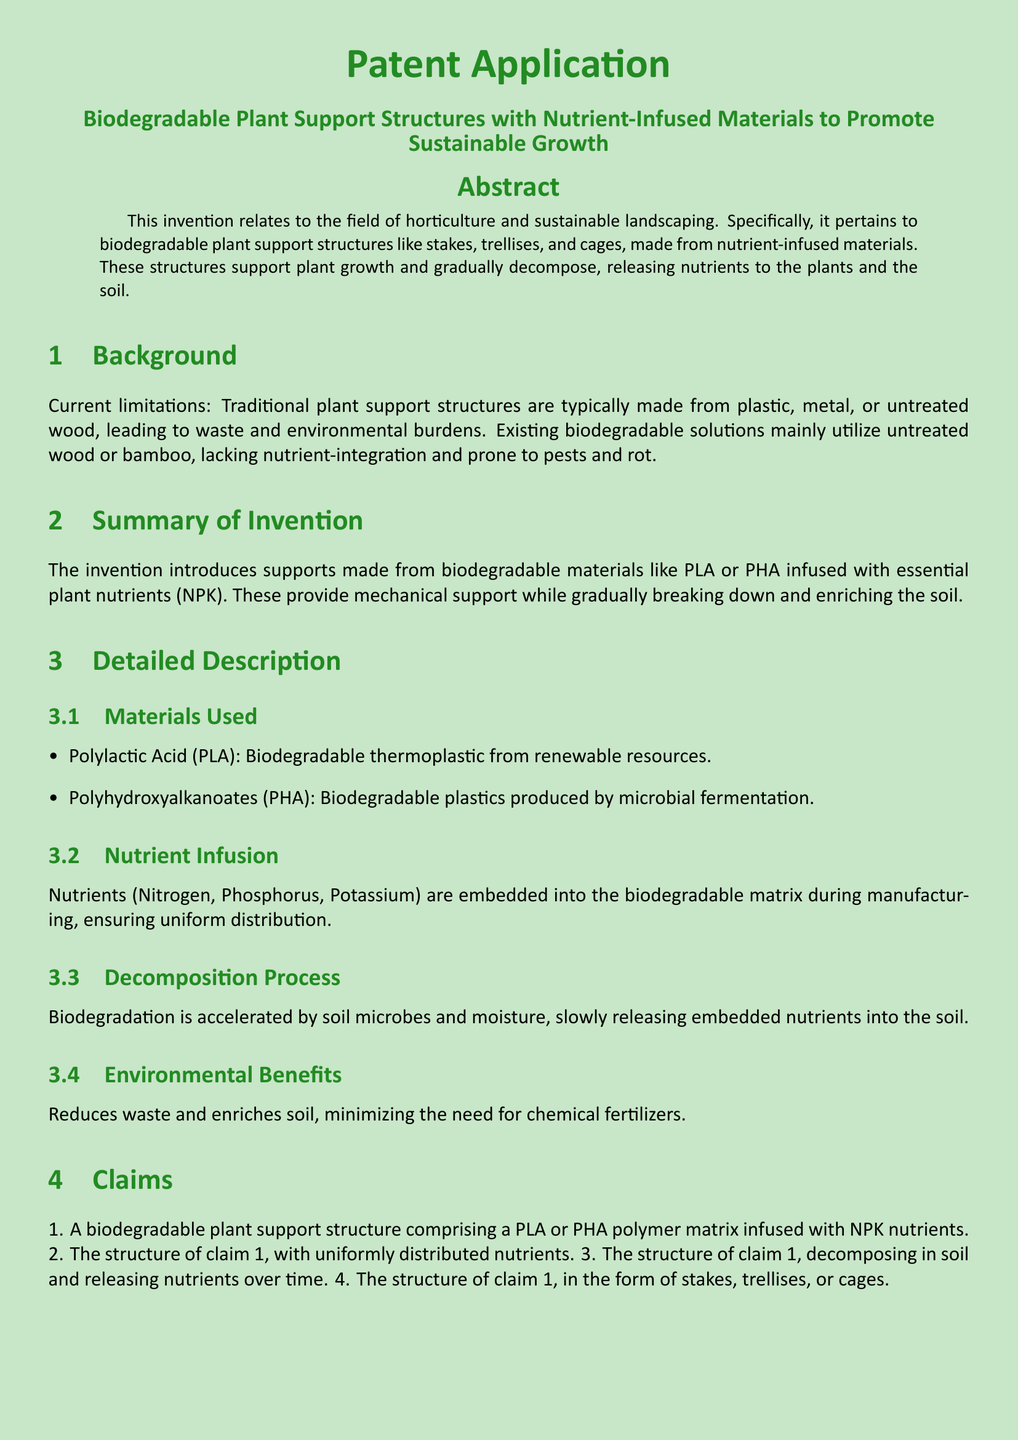what is the title of the patent application? The title is the main heading of the document and identifies the invention being claimed.
Answer: Biodegradable Plant Support Structures with Nutrient-Infused Materials to Promote Sustainable Growth what materials are listed for making plant supports? The materials section details the types of biodegradable materials mentioned in the invention.
Answer: PLA and PHA what nutrients are infused in the plant supports? The nutrient infusion section specifies the essential nutrients embedded in the plant support structures.
Answer: Nitrogen, Phosphorus, Potassium how does the decomposition process occur? This part of the document explains how the plant support structures break down releasing nutrients.
Answer: Accelerated by soil microbes and moisture which plants are examples for application of the invention? The examples of applications section provides practical uses for the biodegradable structures.
Answer: Tomato Plants, Vine Crops, Flower Gardens what claim states the form of the structure? Claims indicate what the invention encompasses; this claim specifies the structural forms.
Answer: Claim 4 what environmental benefit does the invention provide? The environmental benefits section explains the advantages of the invention in landscaping.
Answer: Reduces waste and enriches soil 